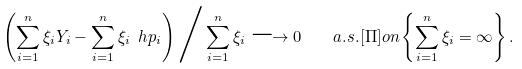Convert formula to latex. <formula><loc_0><loc_0><loc_500><loc_500>\left ( \sum _ { i = 1 } ^ { n } \xi _ { i } Y _ { i } - \sum _ { i = 1 } ^ { n } \xi _ { i } \ h p _ { i } \right ) \Big / \sum _ { i = 1 } ^ { n } \xi _ { i } \longrightarrow 0 \quad a . s . [ \Pi ] o n \left \{ \sum _ { i = 1 } ^ { n } \xi _ { i } = \infty \right \} .</formula> 